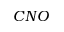Convert formula to latex. <formula><loc_0><loc_0><loc_500><loc_500>C N O</formula> 